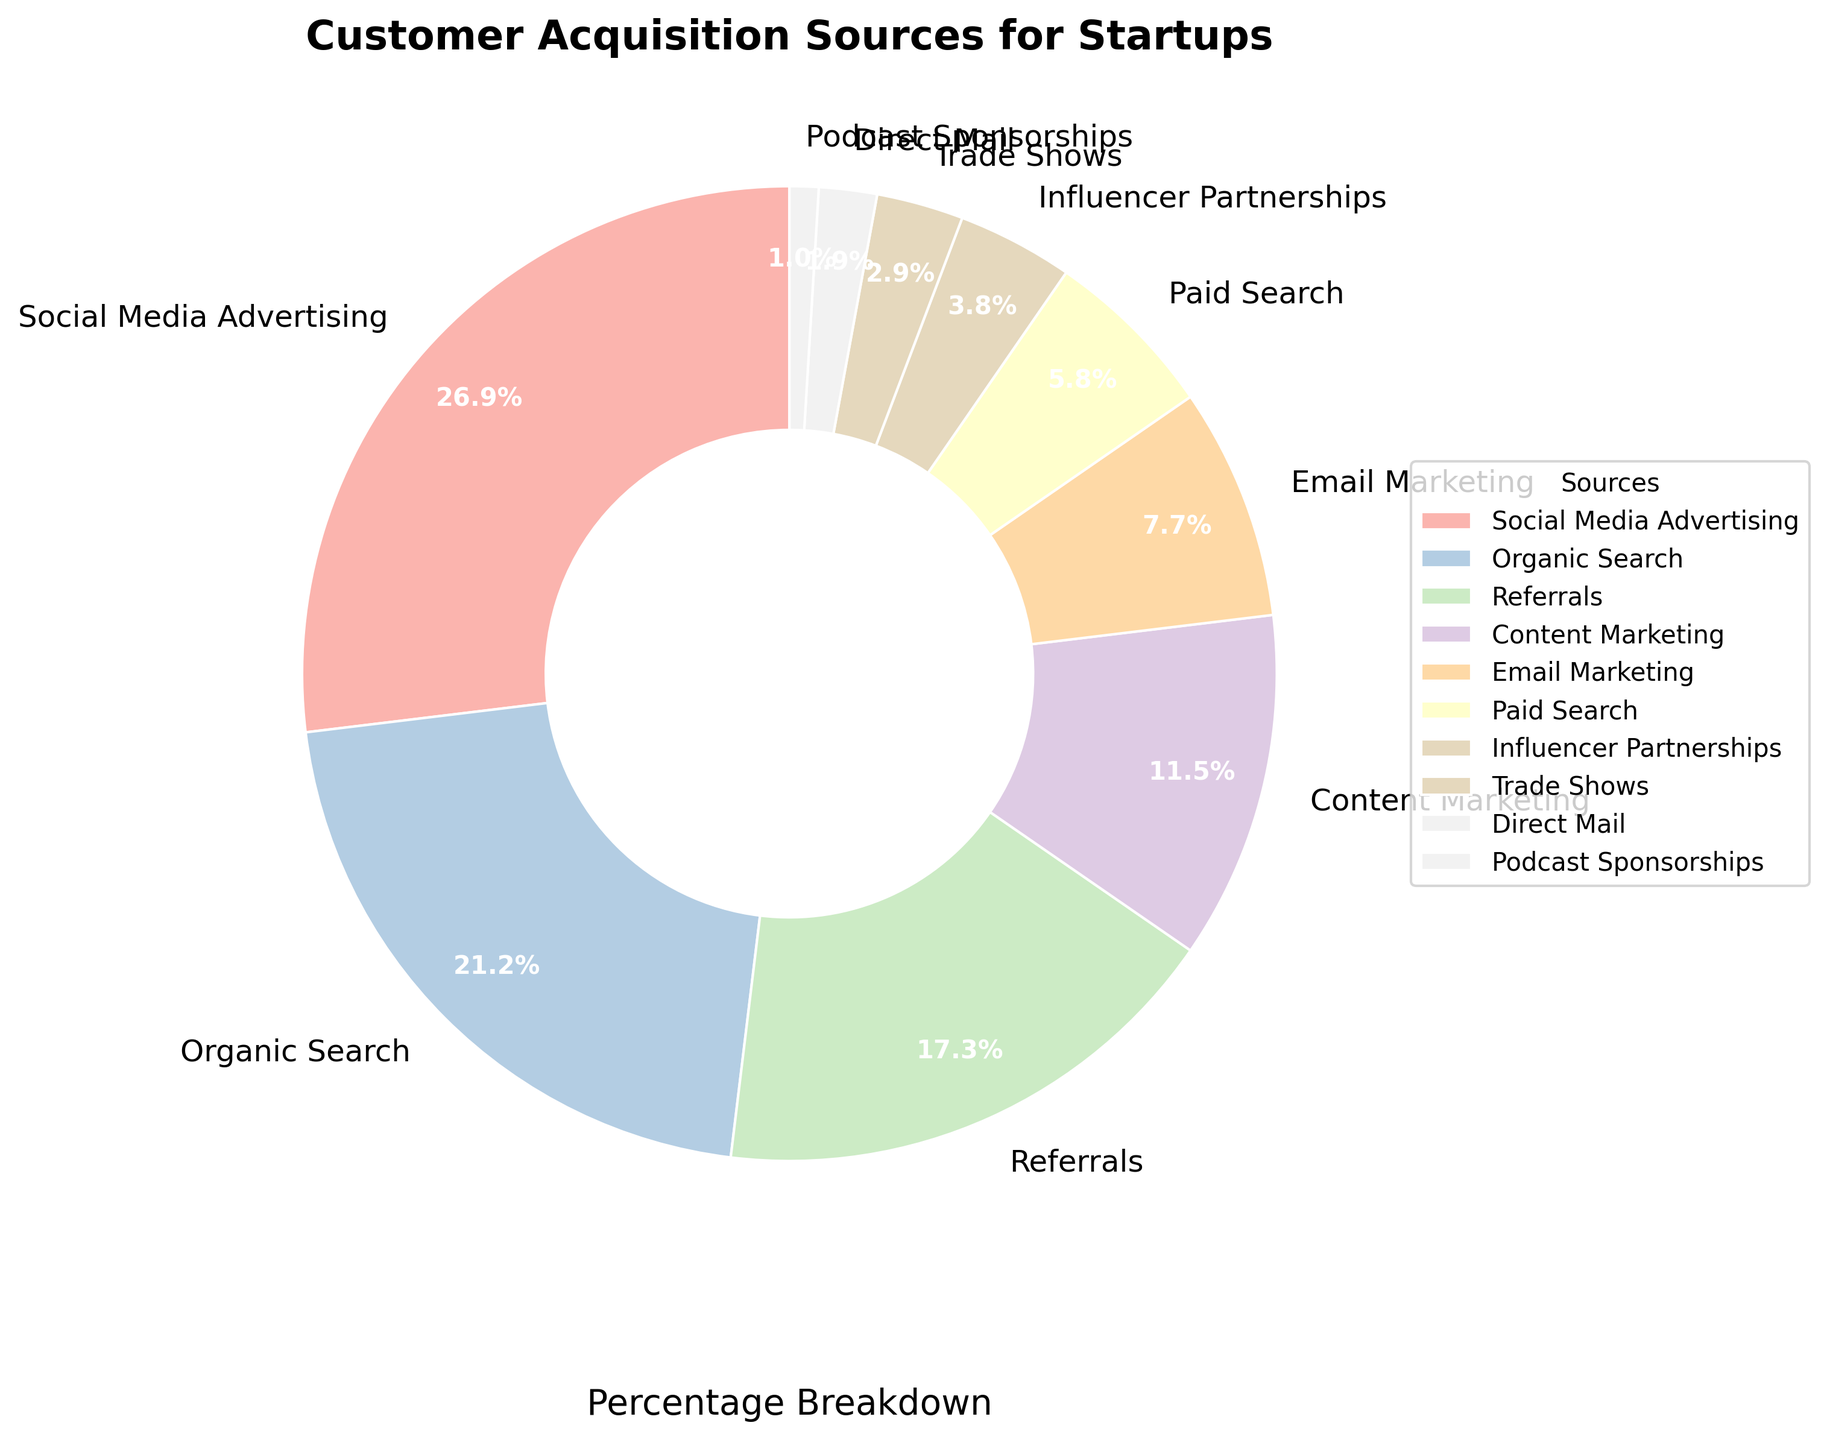Which acquisition source has the highest percentage? The source with the highest percentage can be identified by looking at the largest wedge in the pie chart. The label on this wedge indicates the source, and the percentage is displayed alongside it. The segment for "Social Media Advertising" is the largest, with a percentage label of 28%.
Answer: Social Media Advertising Which acquisition source has the lowest percentage? To find the source with the lowest percentage, look for the smallest wedge in the pie chart. The label on this wedge indicates the source, and the percentage is displayed alongside it. The segment for "Podcast Sponsorships" is the smallest, with a percentage label of 1%.
Answer: Podcast Sponsorships What's the total percentage of acquisition sources from paid channels (Social Media Advertising, Paid Search, Influencer Partnerships)? Sum the percentages of Social Media Advertising (28%), Paid Search (6%), and Influencer Partnerships (4%). The total is 28 + 6 + 4.
Answer: 38% Which source has a larger share, Organic Search or Content Marketing, and by how much? Compare the two sources by looking at their wedges. "Organic Search" has a percentage of 22%, while "Content Marketing" has 12%. The difference is 22 - 12.
Answer: Organic Search by 10% How much higher is the percentage for Referrals compared to Email Marketing? Look at the percentages for Referrals and Email Marketing. Referrals have 18%, and Email Marketing has 8%. Subtract the percentage of Email Marketing from Referrals: 18 - 8.
Answer: 10% Between Trade Shows and Direct Mail, which source has a higher percentage and by how much? Compare the wedges for Trade Shows and Direct Mail. Trade Shows have 3%, and Direct Mail has 2%. The difference is 3 - 2.
Answer: Trade Shows by 1% What's the combined percentage of organic sources (Organic Search, Referrals, and Content Marketing)? Sum the percentages of Organic Search (22%), Referrals (18%), and Content Marketing (12%). The total is 22 + 18 + 12.
Answer: 52% Is the percentage for Social Media Advertising more than double that for Influencer Partnerships? Compare the percentage of Social Media Advertising (28%) to double the percentage of Influencer Partnerships (4%). Double of 4 is 8, and 28 is greater than 8.
Answer: Yes Are the percentages for Organic Search and Referrals combined greater than that for Social Media Advertising? Sum the percentages of Organic Search (22%) and Referrals (18%), and compare the result to the percentage for Social Media Advertising (28%). The combined total is 22 + 18 = 40, which is greater than 28.
Answer: Yes, 40% vs 28% Which colors are used for the wedges representing Email Marketing and Paid Search? Examine the pie chart and identify the colors used for the wedges. Note the positions of the Email Marketing and Paid Search wedges and describe their colors.
Answer: Light pink for Email Marketing, and light blue for Paid Search 